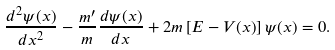Convert formula to latex. <formula><loc_0><loc_0><loc_500><loc_500>\frac { d ^ { 2 } \psi ( x ) } { d x ^ { 2 } } - \frac { m ^ { \prime } } { m } \frac { d \psi ( x ) } { d x } + 2 m \left [ { E - V ( x ) } \right ] \psi ( x ) = 0 .</formula> 